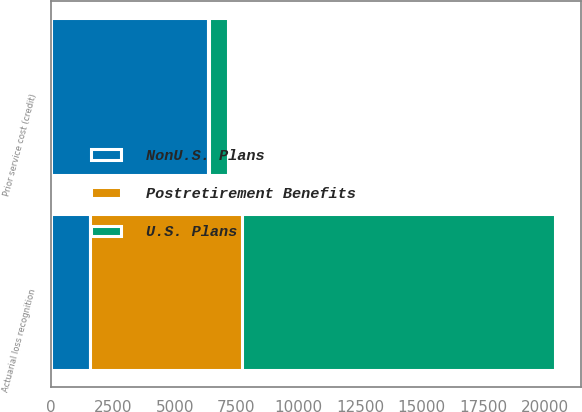Convert chart to OTSL. <chart><loc_0><loc_0><loc_500><loc_500><stacked_bar_chart><ecel><fcel>Actuarial loss recognition<fcel>Prior service cost (credit)<nl><fcel>Postretirement Benefits<fcel>6152<fcel>43<nl><fcel>U.S. Plans<fcel>12680<fcel>794<nl><fcel>NonU.S. Plans<fcel>1580<fcel>6335<nl></chart> 